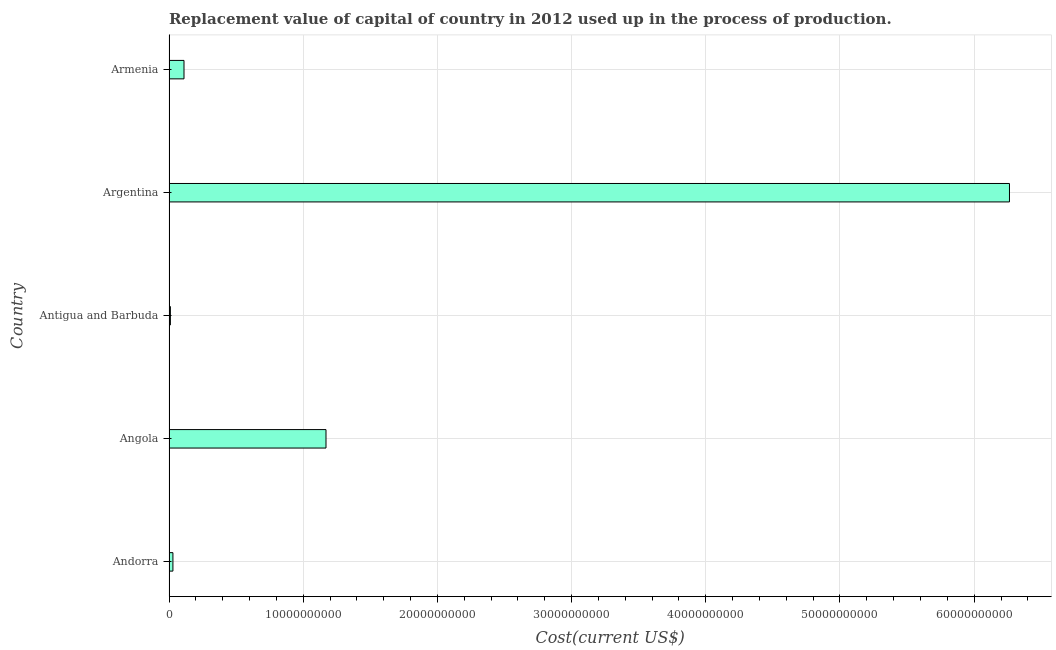Does the graph contain grids?
Keep it short and to the point. Yes. What is the title of the graph?
Provide a short and direct response. Replacement value of capital of country in 2012 used up in the process of production. What is the label or title of the X-axis?
Keep it short and to the point. Cost(current US$). What is the consumption of fixed capital in Argentina?
Offer a terse response. 6.26e+1. Across all countries, what is the maximum consumption of fixed capital?
Make the answer very short. 6.26e+1. Across all countries, what is the minimum consumption of fixed capital?
Provide a succinct answer. 1.04e+08. In which country was the consumption of fixed capital minimum?
Provide a short and direct response. Antigua and Barbuda. What is the sum of the consumption of fixed capital?
Offer a very short reply. 7.58e+1. What is the difference between the consumption of fixed capital in Antigua and Barbuda and Armenia?
Ensure brevity in your answer.  -1.01e+09. What is the average consumption of fixed capital per country?
Keep it short and to the point. 1.52e+1. What is the median consumption of fixed capital?
Your answer should be very brief. 1.12e+09. What is the ratio of the consumption of fixed capital in Andorra to that in Antigua and Barbuda?
Your answer should be very brief. 2.8. Is the consumption of fixed capital in Angola less than that in Armenia?
Keep it short and to the point. No. Is the difference between the consumption of fixed capital in Antigua and Barbuda and Argentina greater than the difference between any two countries?
Make the answer very short. Yes. What is the difference between the highest and the second highest consumption of fixed capital?
Keep it short and to the point. 5.09e+1. What is the difference between the highest and the lowest consumption of fixed capital?
Your response must be concise. 6.25e+1. In how many countries, is the consumption of fixed capital greater than the average consumption of fixed capital taken over all countries?
Offer a very short reply. 1. How many bars are there?
Keep it short and to the point. 5. What is the difference between two consecutive major ticks on the X-axis?
Give a very brief answer. 1.00e+1. What is the Cost(current US$) in Andorra?
Your response must be concise. 2.92e+08. What is the Cost(current US$) of Angola?
Your answer should be compact. 1.17e+1. What is the Cost(current US$) in Antigua and Barbuda?
Keep it short and to the point. 1.04e+08. What is the Cost(current US$) of Argentina?
Ensure brevity in your answer.  6.26e+1. What is the Cost(current US$) in Armenia?
Provide a short and direct response. 1.12e+09. What is the difference between the Cost(current US$) in Andorra and Angola?
Give a very brief answer. -1.14e+1. What is the difference between the Cost(current US$) in Andorra and Antigua and Barbuda?
Keep it short and to the point. 1.88e+08. What is the difference between the Cost(current US$) in Andorra and Argentina?
Make the answer very short. -6.23e+1. What is the difference between the Cost(current US$) in Andorra and Armenia?
Offer a very short reply. -8.26e+08. What is the difference between the Cost(current US$) in Angola and Antigua and Barbuda?
Offer a very short reply. 1.16e+1. What is the difference between the Cost(current US$) in Angola and Argentina?
Your answer should be compact. -5.09e+1. What is the difference between the Cost(current US$) in Angola and Armenia?
Your response must be concise. 1.06e+1. What is the difference between the Cost(current US$) in Antigua and Barbuda and Argentina?
Provide a succinct answer. -6.25e+1. What is the difference between the Cost(current US$) in Antigua and Barbuda and Armenia?
Offer a very short reply. -1.01e+09. What is the difference between the Cost(current US$) in Argentina and Armenia?
Keep it short and to the point. 6.15e+1. What is the ratio of the Cost(current US$) in Andorra to that in Angola?
Offer a terse response. 0.03. What is the ratio of the Cost(current US$) in Andorra to that in Antigua and Barbuda?
Provide a short and direct response. 2.8. What is the ratio of the Cost(current US$) in Andorra to that in Argentina?
Offer a terse response. 0.01. What is the ratio of the Cost(current US$) in Andorra to that in Armenia?
Offer a very short reply. 0.26. What is the ratio of the Cost(current US$) in Angola to that in Antigua and Barbuda?
Make the answer very short. 112.25. What is the ratio of the Cost(current US$) in Angola to that in Argentina?
Provide a short and direct response. 0.19. What is the ratio of the Cost(current US$) in Angola to that in Armenia?
Keep it short and to the point. 10.46. What is the ratio of the Cost(current US$) in Antigua and Barbuda to that in Argentina?
Give a very brief answer. 0. What is the ratio of the Cost(current US$) in Antigua and Barbuda to that in Armenia?
Provide a succinct answer. 0.09. What is the ratio of the Cost(current US$) in Argentina to that in Armenia?
Offer a terse response. 56.02. 